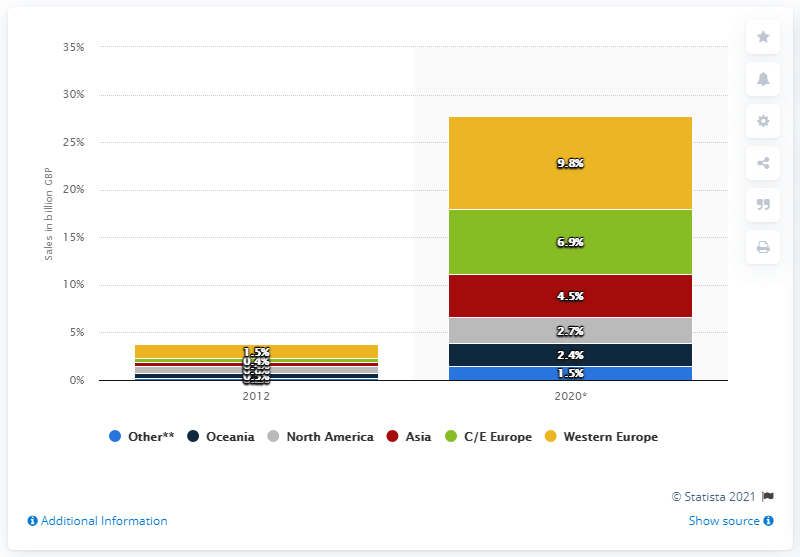Identify some key points in this picture. E-commerce sales to Europe in 2020 are projected to reach a significant milestone, with forecasts predicting that they will reach 9.8 billion dollars. The regional distribution of international e-commerce sales of UK retailers was displayed in 2012. 